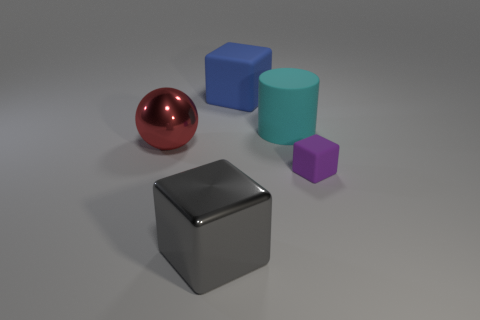There is a large gray thing that is the same shape as the tiny rubber thing; what is it made of?
Your response must be concise. Metal. How many small purple matte things are the same shape as the gray metallic object?
Provide a succinct answer. 1. How many small brown blocks are there?
Ensure brevity in your answer.  0. Does the rubber object that is in front of the large cyan thing have the same shape as the cyan matte thing?
Your response must be concise. No. There is a cyan cylinder that is the same size as the blue matte cube; what is its material?
Provide a succinct answer. Rubber. Are there any large blue objects that have the same material as the gray block?
Your answer should be very brief. No. Does the blue object have the same shape as the large metal thing behind the small purple object?
Your answer should be very brief. No. How many things are both right of the large cyan cylinder and on the left side of the large metallic cube?
Your answer should be very brief. 0. Do the ball and the big cube that is left of the blue cube have the same material?
Offer a very short reply. Yes. Are there the same number of big gray shiny blocks on the left side of the blue rubber block and tiny gray metallic spheres?
Give a very brief answer. No. 